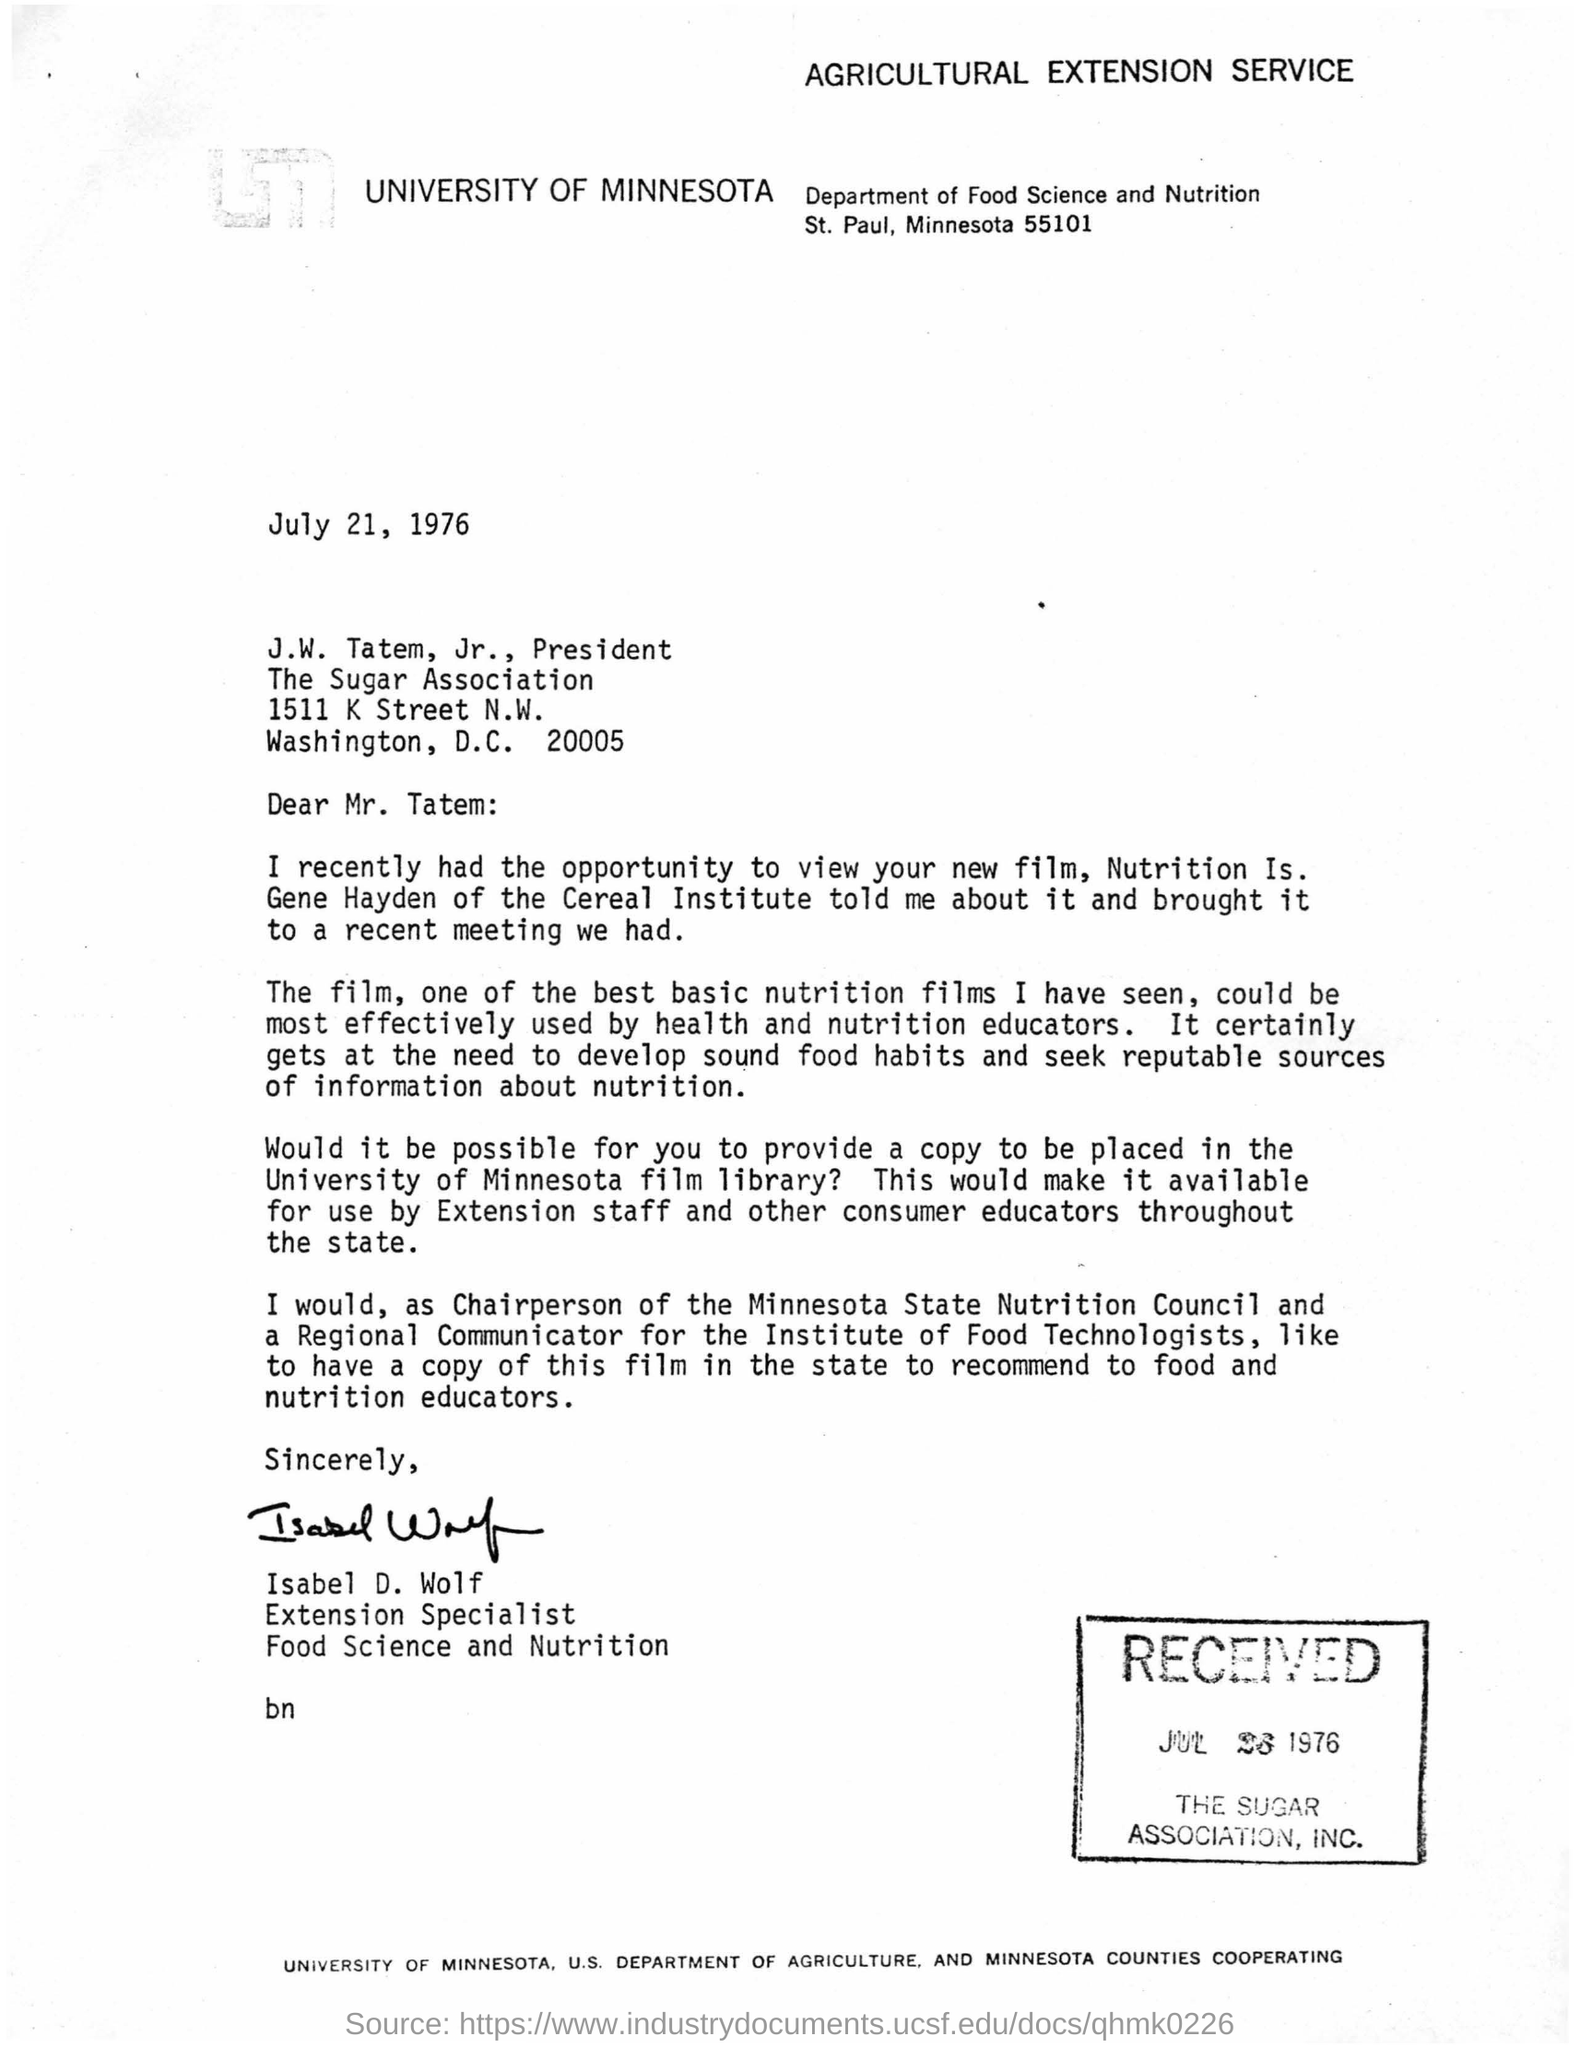Identify some key points in this picture. The University of Minnesota wrote the letter. The writer of the letter is Isabel D. Wolf. The letter was written on July 21, 1976. 